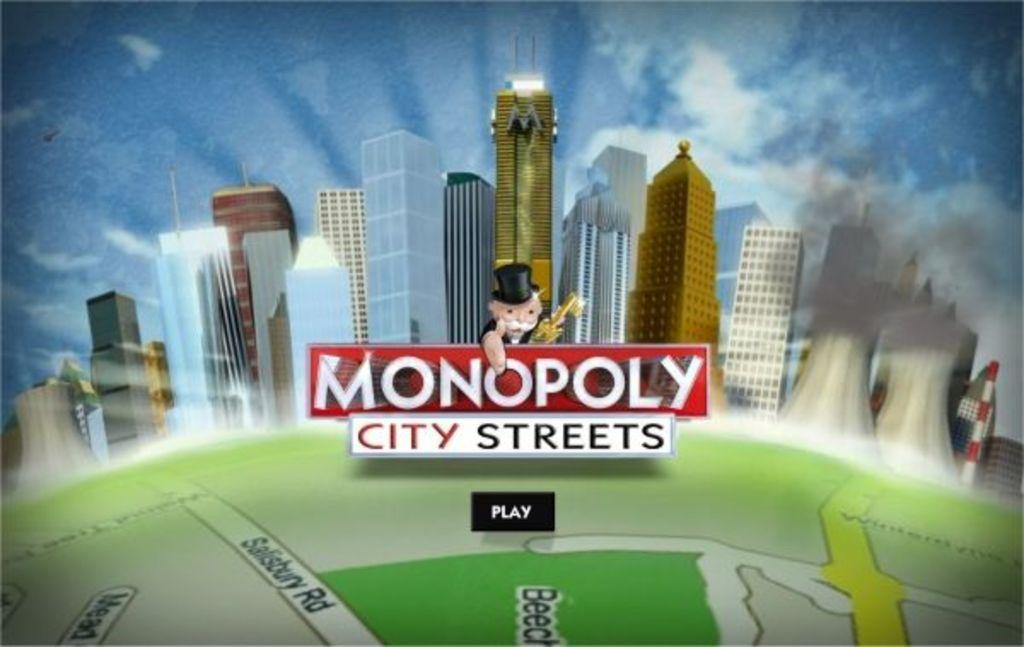<image>
Give a short and clear explanation of the subsequent image. A screen of the game Monopoly, city streets edition 